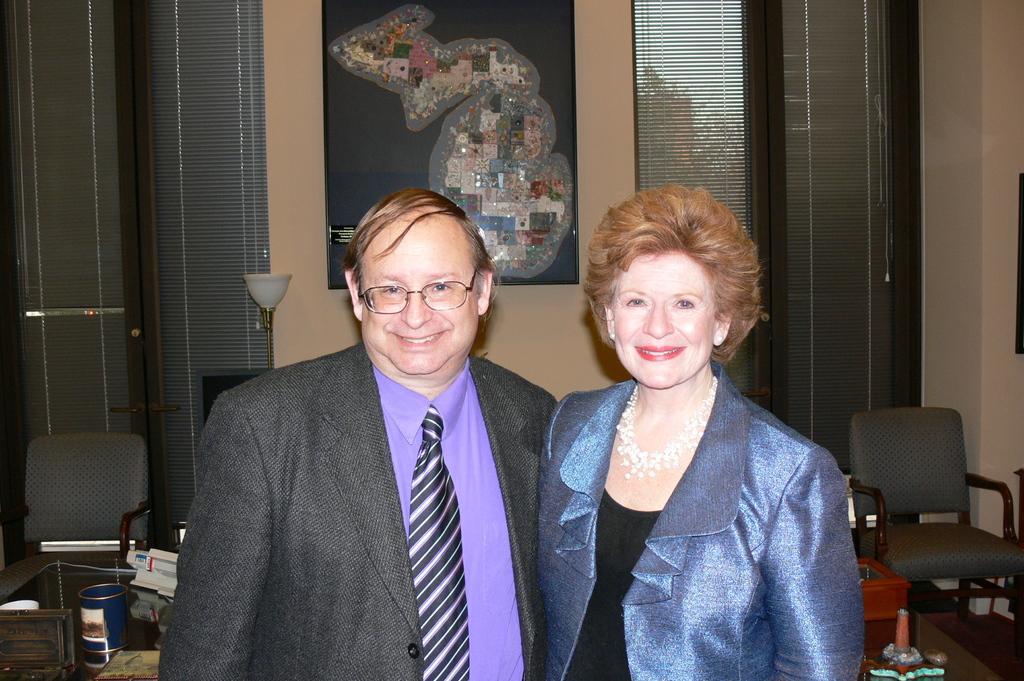Can you describe this image briefly? In this Image I see a man and a woman and both of them are smiling. In the background I see few chairs, a table on which there are many things and the frame on the wall. 